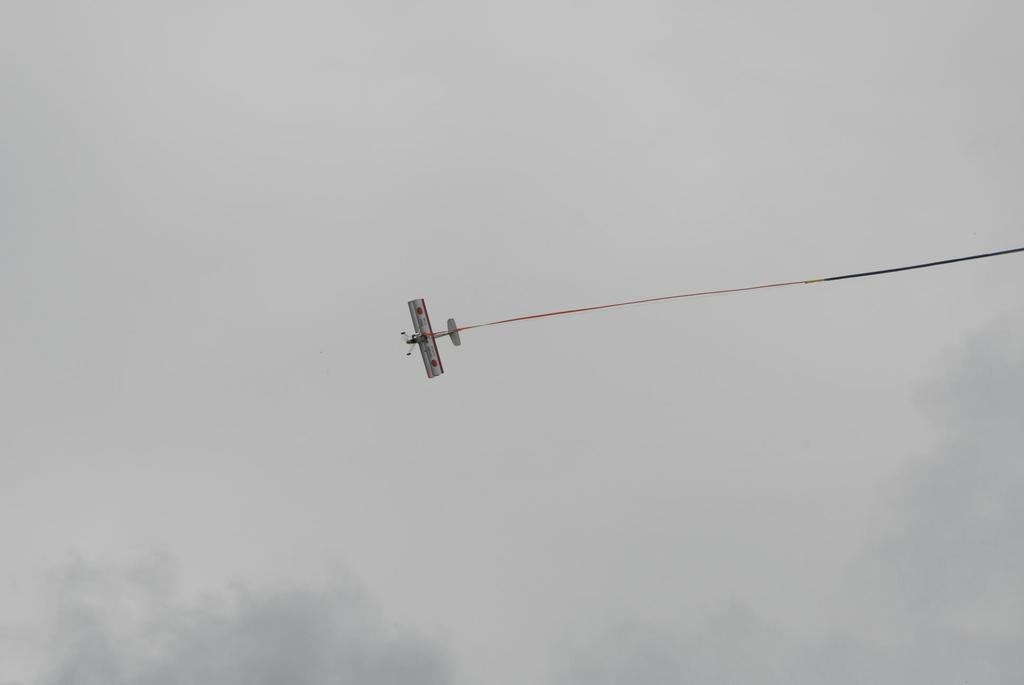What type of aircraft is shown in the image? There is a white and red color aircraft in the image. What is the aircraft doing in the image? The aircraft is flying in the sky. Can you describe any additional details visible in the image? There is smoke visible in the image. What sign is the aircraft holding up in the image? There is no sign visible in the image; the aircraft is simply flying in the sky. 